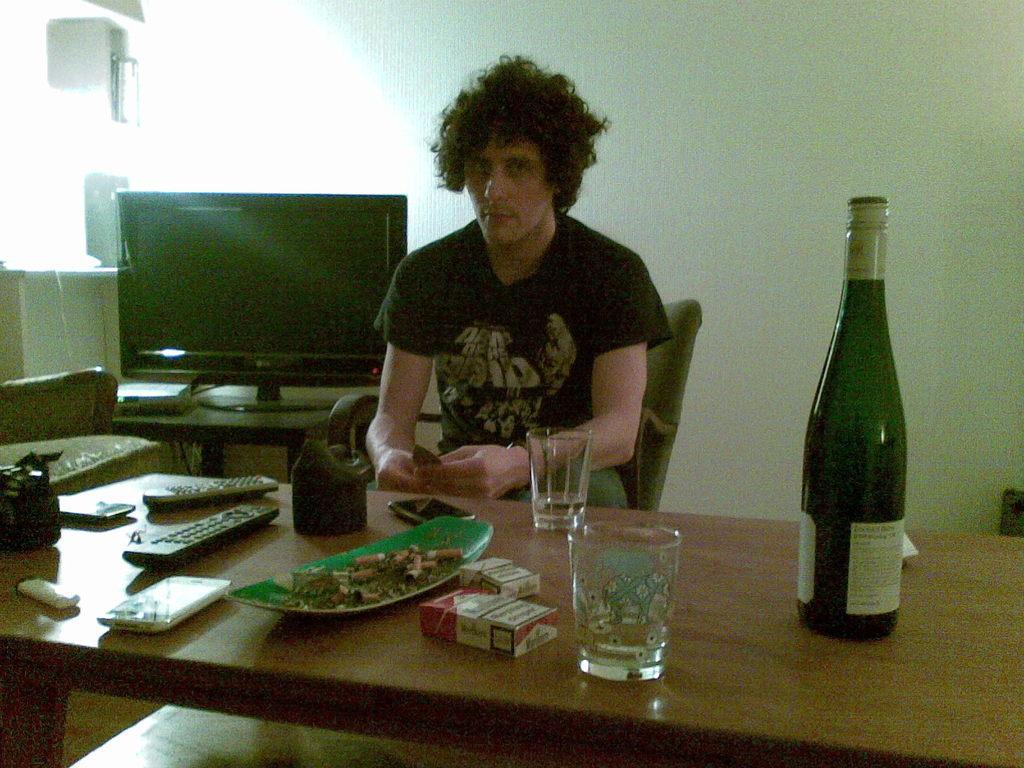Please provide a concise description of this image. In the image we can see there is a person who is sitting on chair and in front of table there is a remote, wine bottle, glass, cigarette packets and a mobile phone and an ash tray and behind him there is a television. 